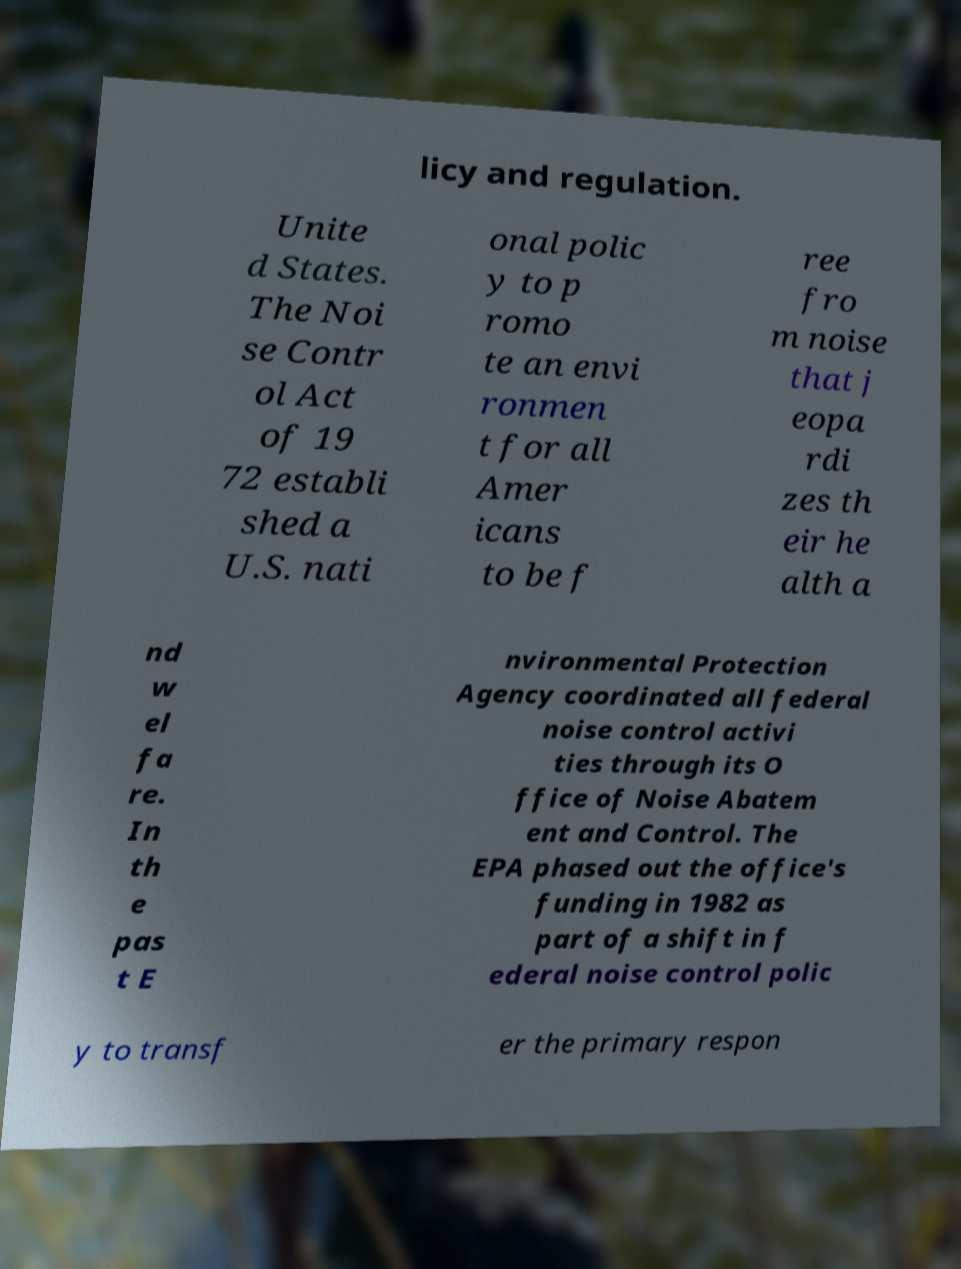Can you read and provide the text displayed in the image?This photo seems to have some interesting text. Can you extract and type it out for me? licy and regulation. Unite d States. The Noi se Contr ol Act of 19 72 establi shed a U.S. nati onal polic y to p romo te an envi ronmen t for all Amer icans to be f ree fro m noise that j eopa rdi zes th eir he alth a nd w el fa re. In th e pas t E nvironmental Protection Agency coordinated all federal noise control activi ties through its O ffice of Noise Abatem ent and Control. The EPA phased out the office's funding in 1982 as part of a shift in f ederal noise control polic y to transf er the primary respon 